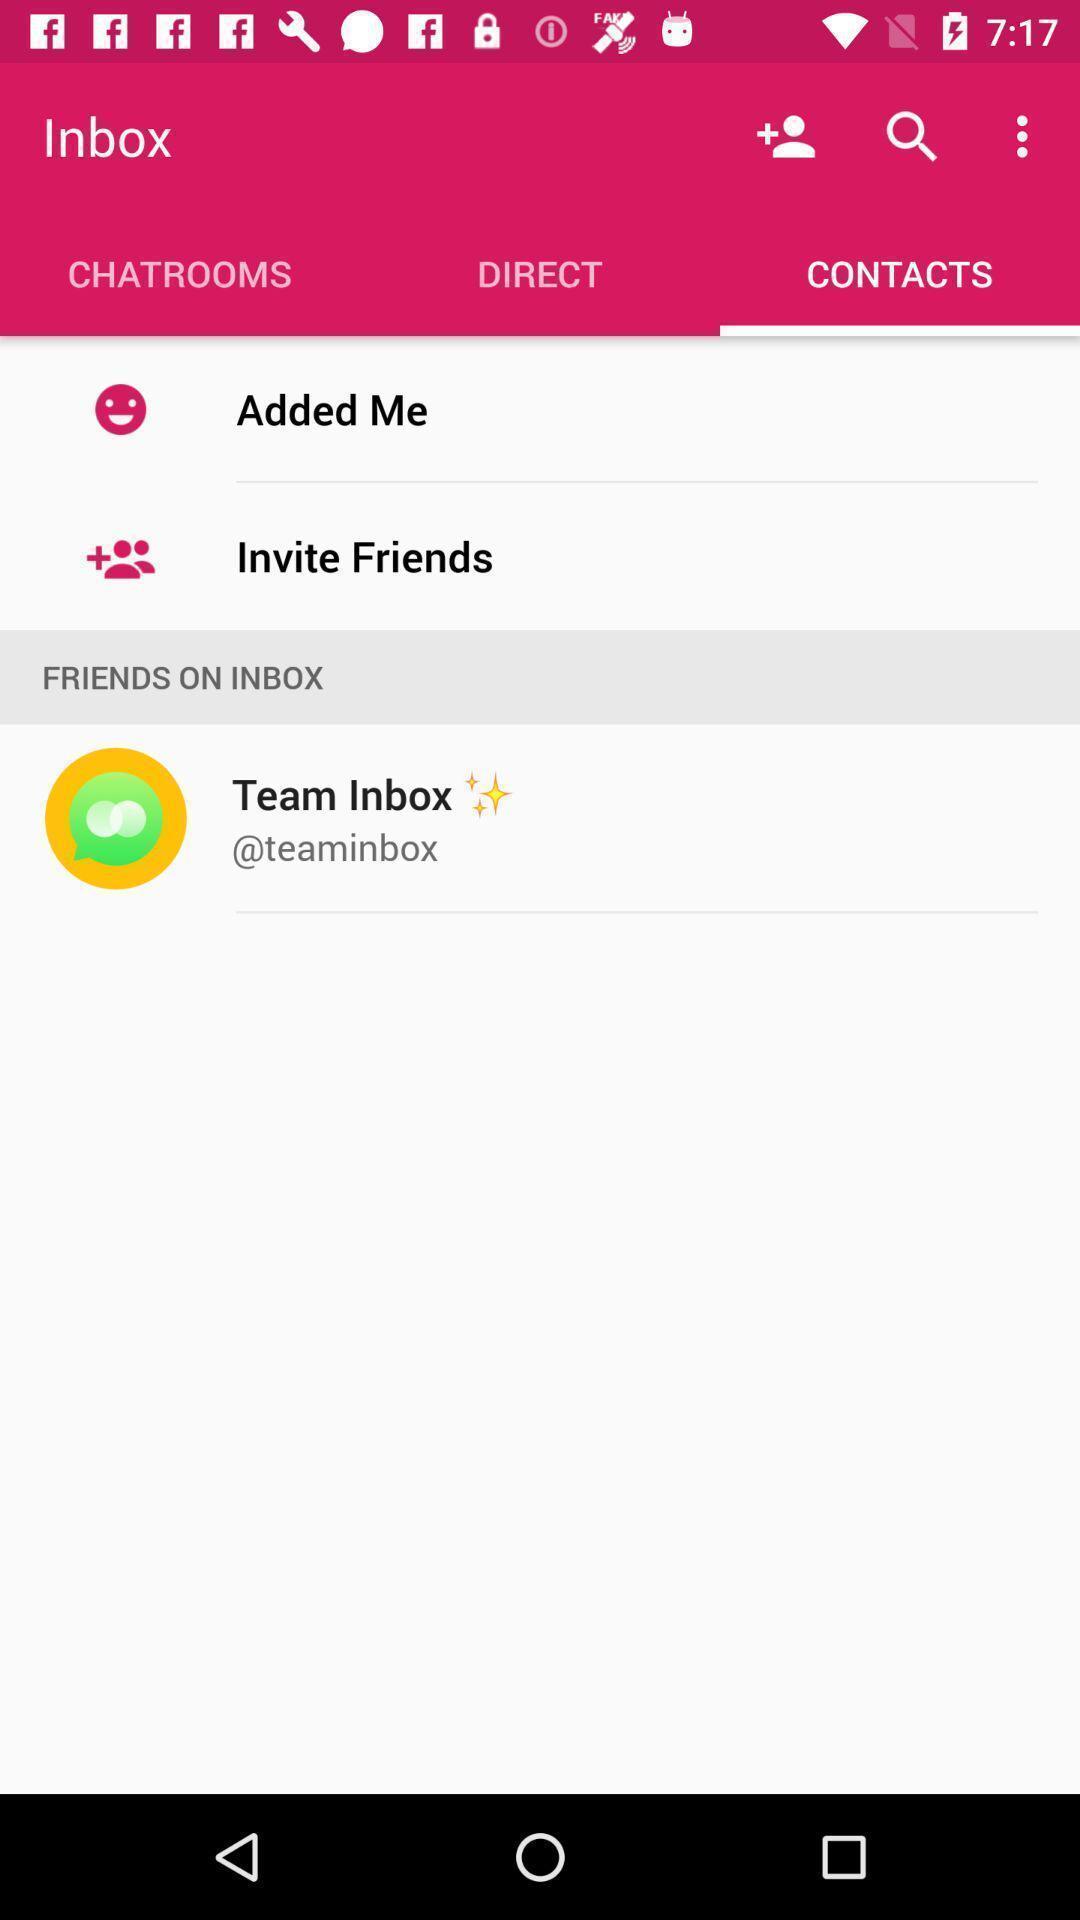Describe the content in this image. Page is showing contacts and friends on inbox. 